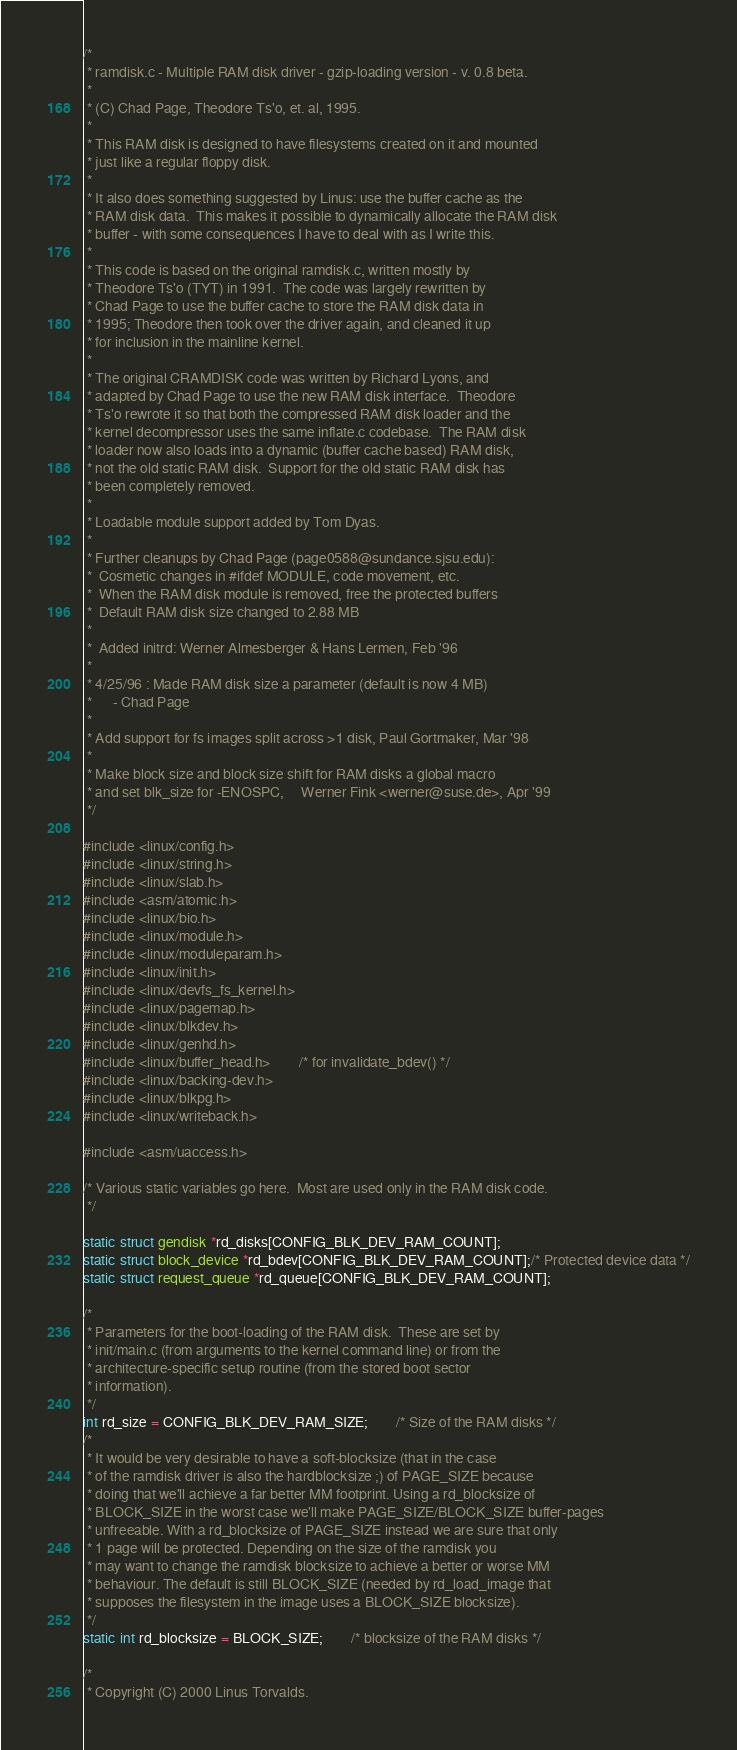<code> <loc_0><loc_0><loc_500><loc_500><_C_>/*
 * ramdisk.c - Multiple RAM disk driver - gzip-loading version - v. 0.8 beta.
 *
 * (C) Chad Page, Theodore Ts'o, et. al, 1995.
 *
 * This RAM disk is designed to have filesystems created on it and mounted
 * just like a regular floppy disk.
 *
 * It also does something suggested by Linus: use the buffer cache as the
 * RAM disk data.  This makes it possible to dynamically allocate the RAM disk
 * buffer - with some consequences I have to deal with as I write this.
 *
 * This code is based on the original ramdisk.c, written mostly by
 * Theodore Ts'o (TYT) in 1991.  The code was largely rewritten by
 * Chad Page to use the buffer cache to store the RAM disk data in
 * 1995; Theodore then took over the driver again, and cleaned it up
 * for inclusion in the mainline kernel.
 *
 * The original CRAMDISK code was written by Richard Lyons, and
 * adapted by Chad Page to use the new RAM disk interface.  Theodore
 * Ts'o rewrote it so that both the compressed RAM disk loader and the
 * kernel decompressor uses the same inflate.c codebase.  The RAM disk
 * loader now also loads into a dynamic (buffer cache based) RAM disk,
 * not the old static RAM disk.  Support for the old static RAM disk has
 * been completely removed.
 *
 * Loadable module support added by Tom Dyas.
 *
 * Further cleanups by Chad Page (page0588@sundance.sjsu.edu):
 *	Cosmetic changes in #ifdef MODULE, code movement, etc.
 * 	When the RAM disk module is removed, free the protected buffers
 * 	Default RAM disk size changed to 2.88 MB
 *
 *  Added initrd: Werner Almesberger & Hans Lermen, Feb '96
 *
 * 4/25/96 : Made RAM disk size a parameter (default is now 4 MB)
 *		- Chad Page
 *
 * Add support for fs images split across >1 disk, Paul Gortmaker, Mar '98
 *
 * Make block size and block size shift for RAM disks a global macro
 * and set blk_size for -ENOSPC,     Werner Fink <werner@suse.de>, Apr '99
 */

#include <linux/config.h>
#include <linux/string.h>
#include <linux/slab.h>
#include <asm/atomic.h>
#include <linux/bio.h>
#include <linux/module.h>
#include <linux/moduleparam.h>
#include <linux/init.h>
#include <linux/devfs_fs_kernel.h>
#include <linux/pagemap.h>
#include <linux/blkdev.h>
#include <linux/genhd.h>
#include <linux/buffer_head.h>		/* for invalidate_bdev() */
#include <linux/backing-dev.h>
#include <linux/blkpg.h>
#include <linux/writeback.h>

#include <asm/uaccess.h>

/* Various static variables go here.  Most are used only in the RAM disk code.
 */

static struct gendisk *rd_disks[CONFIG_BLK_DEV_RAM_COUNT];
static struct block_device *rd_bdev[CONFIG_BLK_DEV_RAM_COUNT];/* Protected device data */
static struct request_queue *rd_queue[CONFIG_BLK_DEV_RAM_COUNT];

/*
 * Parameters for the boot-loading of the RAM disk.  These are set by
 * init/main.c (from arguments to the kernel command line) or from the
 * architecture-specific setup routine (from the stored boot sector
 * information).
 */
int rd_size = CONFIG_BLK_DEV_RAM_SIZE;		/* Size of the RAM disks */
/*
 * It would be very desirable to have a soft-blocksize (that in the case
 * of the ramdisk driver is also the hardblocksize ;) of PAGE_SIZE because
 * doing that we'll achieve a far better MM footprint. Using a rd_blocksize of
 * BLOCK_SIZE in the worst case we'll make PAGE_SIZE/BLOCK_SIZE buffer-pages
 * unfreeable. With a rd_blocksize of PAGE_SIZE instead we are sure that only
 * 1 page will be protected. Depending on the size of the ramdisk you
 * may want to change the ramdisk blocksize to achieve a better or worse MM
 * behaviour. The default is still BLOCK_SIZE (needed by rd_load_image that
 * supposes the filesystem in the image uses a BLOCK_SIZE blocksize).
 */
static int rd_blocksize = BLOCK_SIZE;		/* blocksize of the RAM disks */

/*
 * Copyright (C) 2000 Linus Torvalds.</code> 